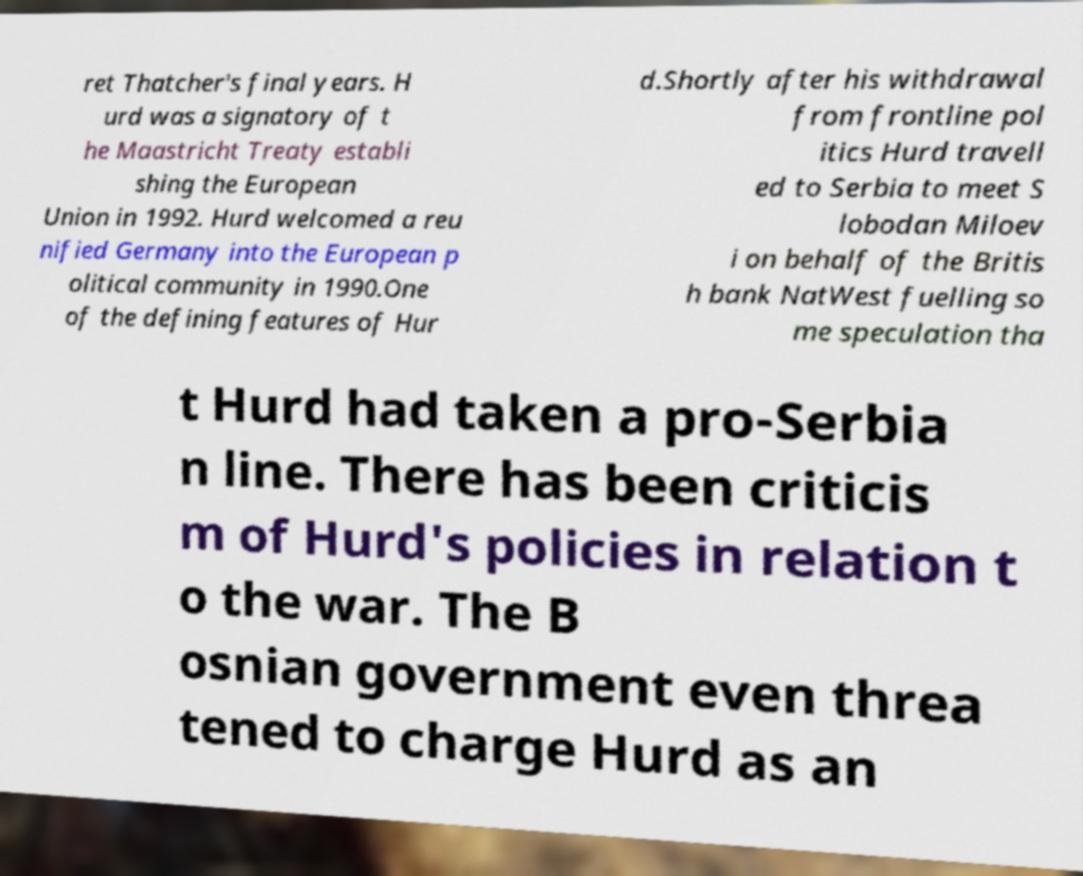Could you assist in decoding the text presented in this image and type it out clearly? ret Thatcher's final years. H urd was a signatory of t he Maastricht Treaty establi shing the European Union in 1992. Hurd welcomed a reu nified Germany into the European p olitical community in 1990.One of the defining features of Hur d.Shortly after his withdrawal from frontline pol itics Hurd travell ed to Serbia to meet S lobodan Miloev i on behalf of the Britis h bank NatWest fuelling so me speculation tha t Hurd had taken a pro-Serbia n line. There has been criticis m of Hurd's policies in relation t o the war. The B osnian government even threa tened to charge Hurd as an 